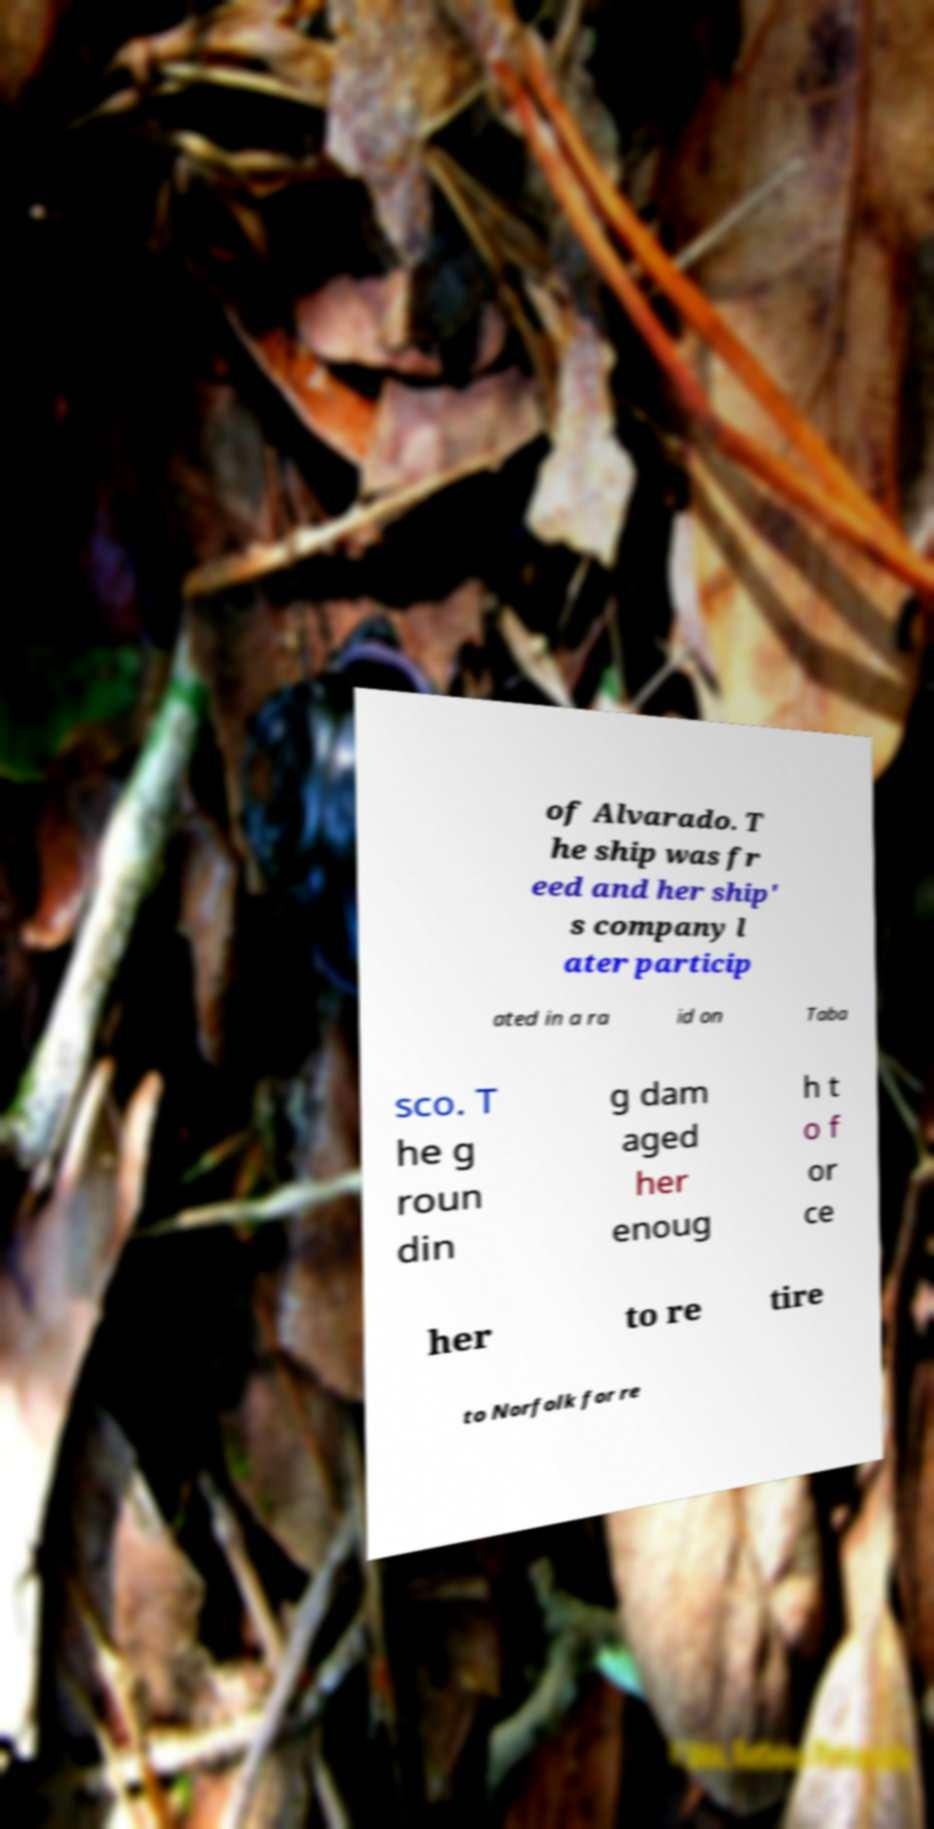Could you extract and type out the text from this image? of Alvarado. T he ship was fr eed and her ship' s company l ater particip ated in a ra id on Taba sco. T he g roun din g dam aged her enoug h t o f or ce her to re tire to Norfolk for re 